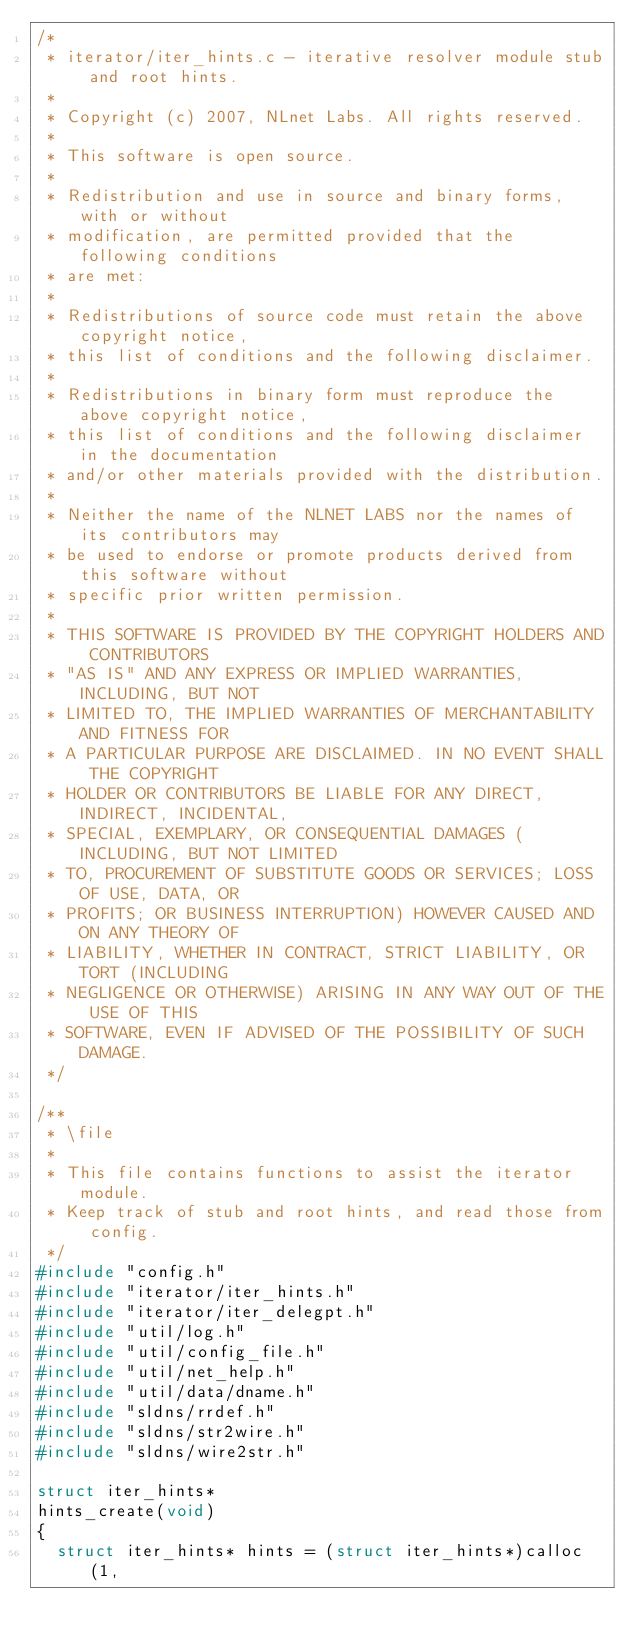Convert code to text. <code><loc_0><loc_0><loc_500><loc_500><_C_>/*
 * iterator/iter_hints.c - iterative resolver module stub and root hints.
 *
 * Copyright (c) 2007, NLnet Labs. All rights reserved.
 *
 * This software is open source.
 * 
 * Redistribution and use in source and binary forms, with or without
 * modification, are permitted provided that the following conditions
 * are met:
 * 
 * Redistributions of source code must retain the above copyright notice,
 * this list of conditions and the following disclaimer.
 * 
 * Redistributions in binary form must reproduce the above copyright notice,
 * this list of conditions and the following disclaimer in the documentation
 * and/or other materials provided with the distribution.
 * 
 * Neither the name of the NLNET LABS nor the names of its contributors may
 * be used to endorse or promote products derived from this software without
 * specific prior written permission.
 * 
 * THIS SOFTWARE IS PROVIDED BY THE COPYRIGHT HOLDERS AND CONTRIBUTORS
 * "AS IS" AND ANY EXPRESS OR IMPLIED WARRANTIES, INCLUDING, BUT NOT
 * LIMITED TO, THE IMPLIED WARRANTIES OF MERCHANTABILITY AND FITNESS FOR
 * A PARTICULAR PURPOSE ARE DISCLAIMED. IN NO EVENT SHALL THE COPYRIGHT
 * HOLDER OR CONTRIBUTORS BE LIABLE FOR ANY DIRECT, INDIRECT, INCIDENTAL,
 * SPECIAL, EXEMPLARY, OR CONSEQUENTIAL DAMAGES (INCLUDING, BUT NOT LIMITED
 * TO, PROCUREMENT OF SUBSTITUTE GOODS OR SERVICES; LOSS OF USE, DATA, OR
 * PROFITS; OR BUSINESS INTERRUPTION) HOWEVER CAUSED AND ON ANY THEORY OF
 * LIABILITY, WHETHER IN CONTRACT, STRICT LIABILITY, OR TORT (INCLUDING
 * NEGLIGENCE OR OTHERWISE) ARISING IN ANY WAY OUT OF THE USE OF THIS
 * SOFTWARE, EVEN IF ADVISED OF THE POSSIBILITY OF SUCH DAMAGE.
 */

/**
 * \file
 *
 * This file contains functions to assist the iterator module.
 * Keep track of stub and root hints, and read those from config.
 */
#include "config.h"
#include "iterator/iter_hints.h"
#include "iterator/iter_delegpt.h"
#include "util/log.h"
#include "util/config_file.h"
#include "util/net_help.h"
#include "util/data/dname.h"
#include "sldns/rrdef.h"
#include "sldns/str2wire.h"
#include "sldns/wire2str.h"

struct iter_hints* 
hints_create(void)
{
	struct iter_hints* hints = (struct iter_hints*)calloc(1,</code> 